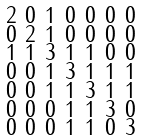Convert formula to latex. <formula><loc_0><loc_0><loc_500><loc_500>\begin{smallmatrix} 2 & 0 & 1 & 0 & 0 & 0 & 0 \\ 0 & 2 & 1 & 0 & 0 & 0 & 0 \\ 1 & 1 & 3 & 1 & 1 & 0 & 0 \\ 0 & 0 & 1 & 3 & 1 & 1 & 1 \\ 0 & 0 & 1 & 1 & 3 & 1 & 1 \\ 0 & 0 & 0 & 1 & 1 & 3 & 0 \\ 0 & 0 & 0 & 1 & 1 & 0 & 3 \end{smallmatrix}</formula> 